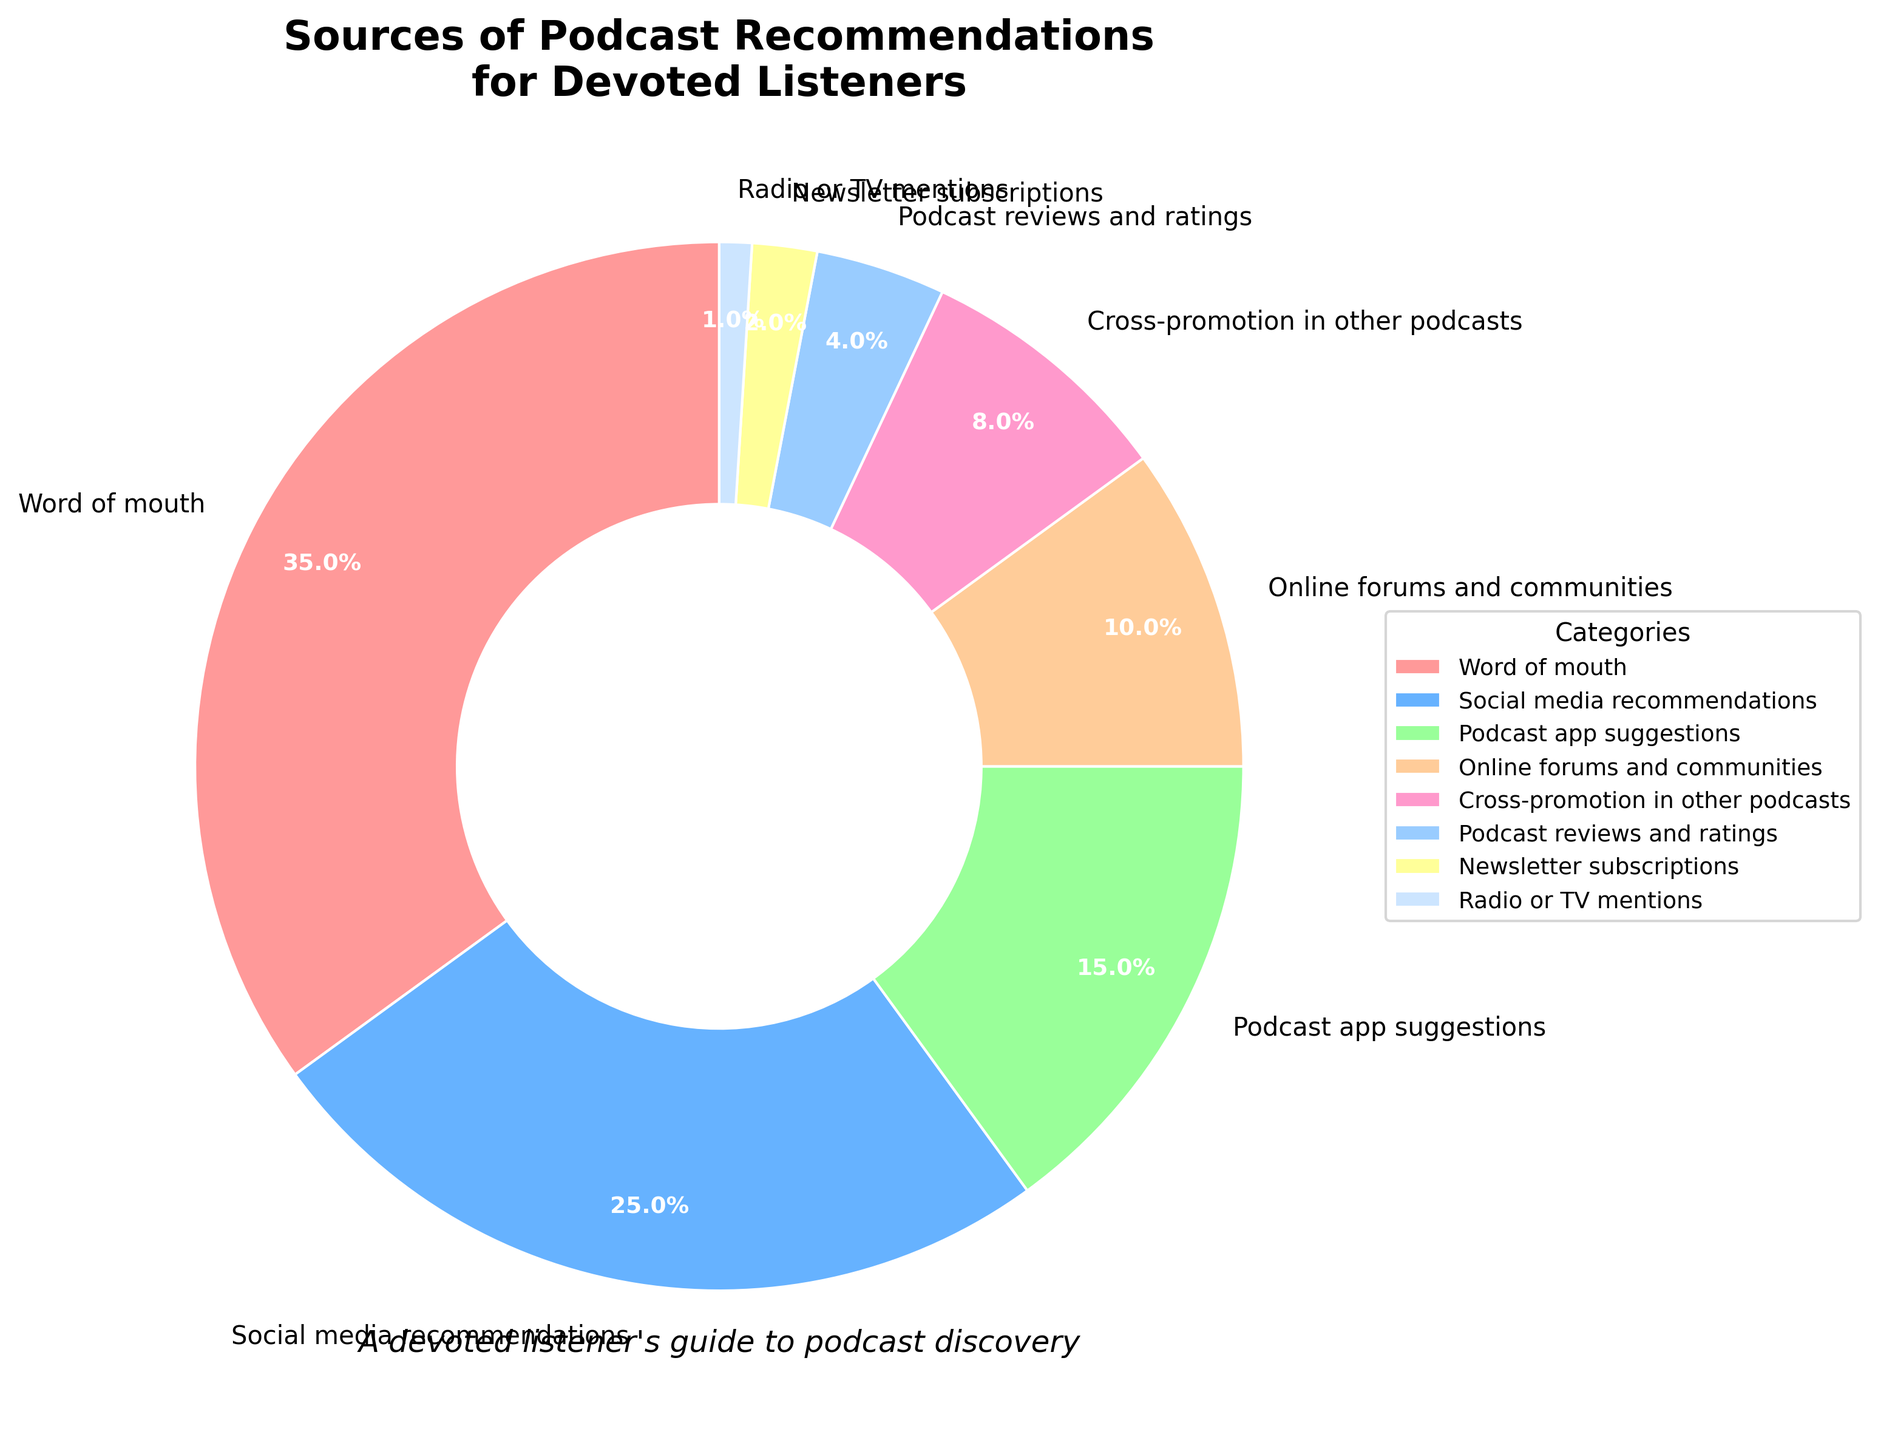What is the most common source of podcast recommendations for devoted listeners? The figure clearly shows that "Word of mouth" has the largest slice of the pie chart, indicating it is the most common source of recommendations.
Answer: Word of mouth How much more popular are social media recommendations compared to podcast reviews and ratings? Social media recommendations account for 25% while podcast reviews and ratings account for 4%. The difference is 25% - 4%.
Answer: 21% Which source of podcast recommendations is the least common? The smallest slice of the pie chart is labeled "Radio or TV mentions", indicating it is the least common source.
Answer: Radio or TV mentions What proportion of recommendations comes from online forums and communities and cross-promotion in other podcasts combined? The percentages are 10% for online forums and 8% for cross-promotion. Adding these together gives 10% + 8%.
Answer: 18% Rank the top three sources of podcast recommendations in order from most to least popular. By examining the sizes of the slices in the pie chart, the top three sources are "Word of mouth" (35%), "Social media recommendations" (25%), and "Podcast app suggestions" (15%).
Answer: Word of mouth > Social media recommendations > Podcast app suggestions Is the percentage of newsletter subscriptions higher or lower than podcast reviews and ratings? Newsletter subscriptions account for 2%, while podcast reviews and ratings account for 4%. 2% is lower than 4%.
Answer: Lower Are online forums and communities more popular than podcast app suggestions? Online forums and communities are at 10%, while podcast app suggestions are at 15%. 10% is lower than 15%.
Answer: No What percentage of recommendations comes from categories other than word of mouth? Since "Word of mouth" accounts for 35%, subtracting this from 100% gives the percentage from all other sources: 100% - 35%.
Answer: 65% Between cross-promotion in other podcasts and social media recommendations, which one is less common, and by how much? Cross-promotion is at 8%, while social media recommendations are at 25%. The difference is 25% - 8%.
Answer: Cross-promotion is less common by 17% What are the combined percentages of the three least common sources of recommendations? The three least common are "Radio or TV mentions" (1%), "Newsletter subscriptions" (2%), and "Podcast reviews and ratings" (4%). Adding these gives 1% + 2% + 4%.
Answer: 7% 